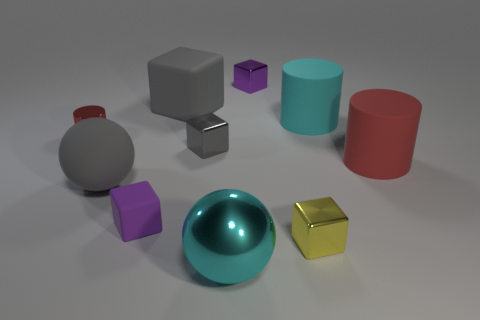There is a purple object that is the same material as the tiny gray object; what is its shape?
Your answer should be very brief. Cube. How big is the gray matte ball?
Your response must be concise. Large. Do the metallic sphere and the cyan rubber object have the same size?
Your answer should be very brief. Yes. What number of things are gray blocks behind the cyan cylinder or big shiny spheres on the left side of the red rubber object?
Provide a succinct answer. 2. What number of small yellow things are in front of the large cylinder that is in front of the large cylinder left of the red matte cylinder?
Your response must be concise. 1. What size is the shiny thing that is behind the big gray matte block?
Offer a terse response. Small. How many red cylinders have the same size as the cyan rubber thing?
Offer a very short reply. 1. Does the gray shiny cube have the same size as the red cylinder that is on the right side of the tiny yellow object?
Your answer should be compact. No. How many things are large blue shiny spheres or gray shiny things?
Make the answer very short. 1. How many small rubber blocks are the same color as the matte sphere?
Offer a very short reply. 0. 